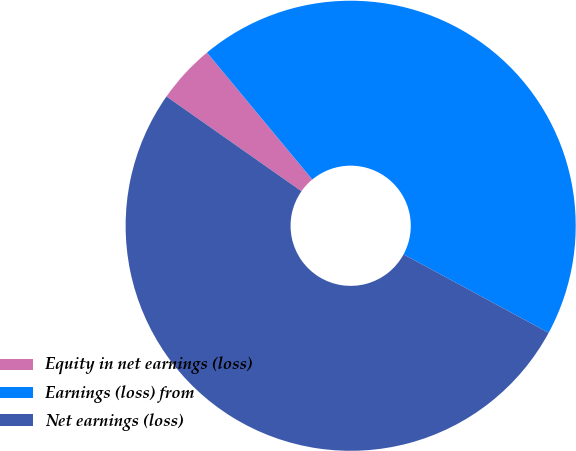Convert chart to OTSL. <chart><loc_0><loc_0><loc_500><loc_500><pie_chart><fcel>Equity in net earnings (loss)<fcel>Earnings (loss) from<fcel>Net earnings (loss)<nl><fcel>4.24%<fcel>43.91%<fcel>51.85%<nl></chart> 